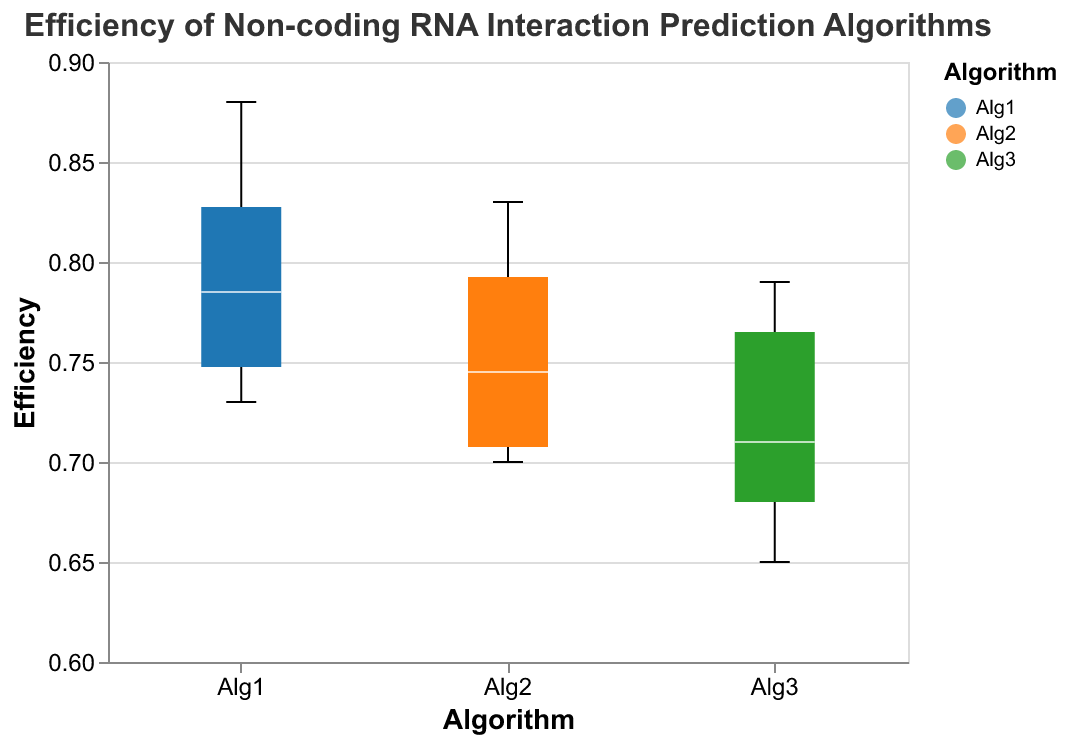What is the range of efficiency for Algorithm 1? To find the range of Algorithm 1, look at the lowest and highest points (whiskers) on the box plot for Algorithm 1. This gives the minimum and maximum values, showing the efficiency range.
Answer: 0.73 to 0.88 What is the median efficiency for Algorithm 2? Identify the median line within the box for Algorithm 2. The line represents the middle value of the dataset for Algorithm 2.
Answer: 0.765 Which algorithm has the lowest minimum efficiency? Look for the algorithm with the lowest end of the whisker (minimum efficiency). Compare the minimum points of each algorithm.
Answer: Algorithm 3 Is the median efficiency of Algorithm 1 higher than Algorithm 3 for lncRNA datasets? Compare the median lines of Algorithm 1 and Algorithm 3 specifically within the lncRNA datasets (Human_lncRNA, Mouse_lncRNA, Arabidopsis_lncRNA, C_elegans_lncRNA). Check if Algorithm 1's median is consistently higher.
Answer: Yes How do the efficiencies of Algorithm 2 vary across different datasets? Observe the spread (whiskers) and box-size of Algorithm 2 across all datasets. This shows the variation in the efficiency of Algorithm 2.
Answer: Varies between 0.70 to 0.83 Which dataset shows the greatest spread in efficiency for Algorithm 3? Look at the length of the whiskers and the size of the box for Algorithm 3 across different datasets. The dataset with the largest total length (difference between minimum and maximum) shows the greatest spread.
Answer: C_elegans Compare the highest efficiencies of Algorithms 1 and 3. Which algorithm has a higher top efficiency? Find the highest points (upper whiskers) for Algorithms 1 and 3 and compare these values to see which algorithm has the higher top efficiency.
Answer: Algorithm 1 Does Algorithm 2 perform consistently better than Algorithm 3 for miRNA datasets? For each miRNA dataset (Human_miRNA, Mouse_miRNA, Arabidopsis_miRNA, C_elegans_miRNA), compare the median values of Algorithm 2 and Algorithm 3 to see if Algorithm 2 is consistently higher.
Answer: Yes Which algorithm has the smallest interquartile range (IQR)? The IQR is the size of the box in each box plot. Compare the box sizes for all algorithms to determine the smallest IQR.
Answer: Algorithm 2 